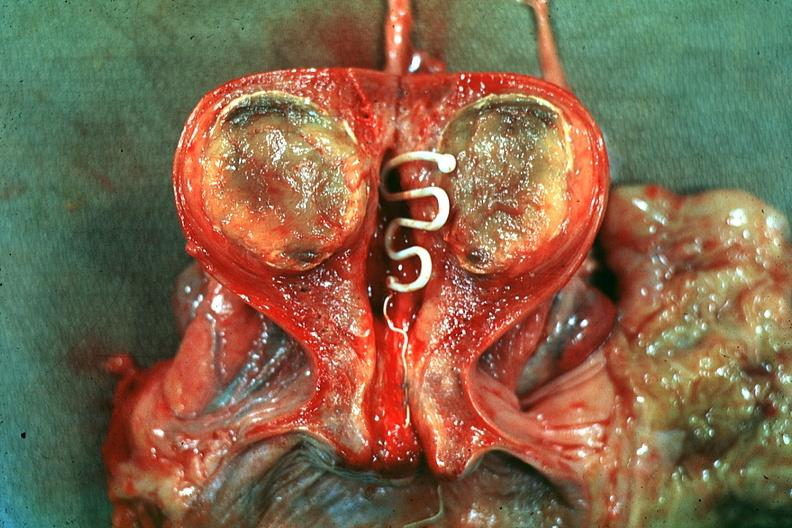what is present?
Answer the question using a single word or phrase. Uterus 